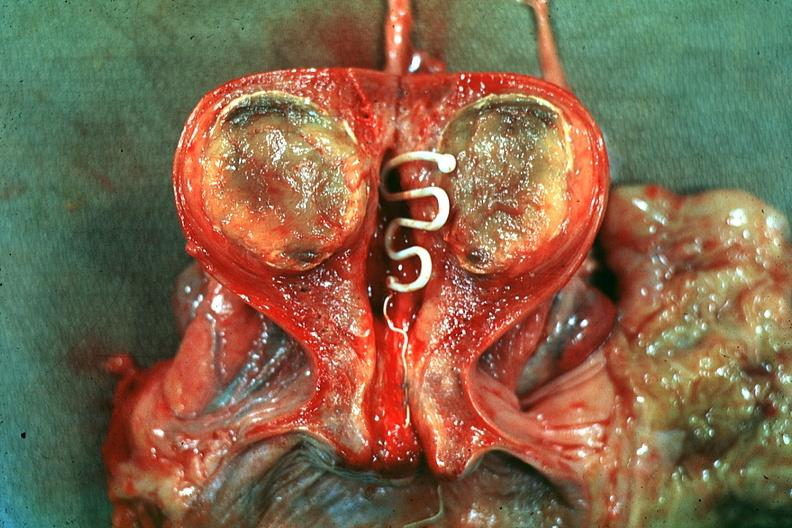what is present?
Answer the question using a single word or phrase. Uterus 